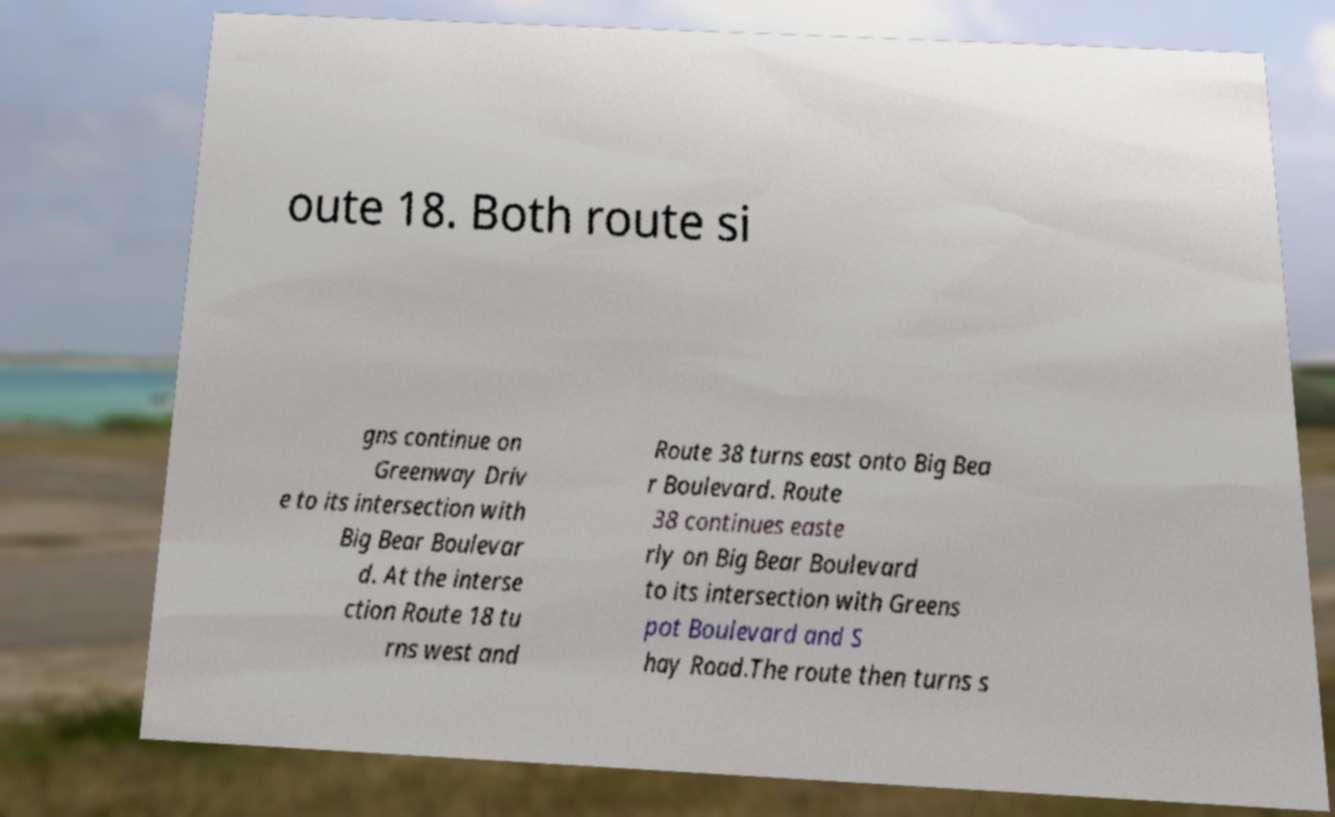Could you assist in decoding the text presented in this image and type it out clearly? oute 18. Both route si gns continue on Greenway Driv e to its intersection with Big Bear Boulevar d. At the interse ction Route 18 tu rns west and Route 38 turns east onto Big Bea r Boulevard. Route 38 continues easte rly on Big Bear Boulevard to its intersection with Greens pot Boulevard and S hay Road.The route then turns s 